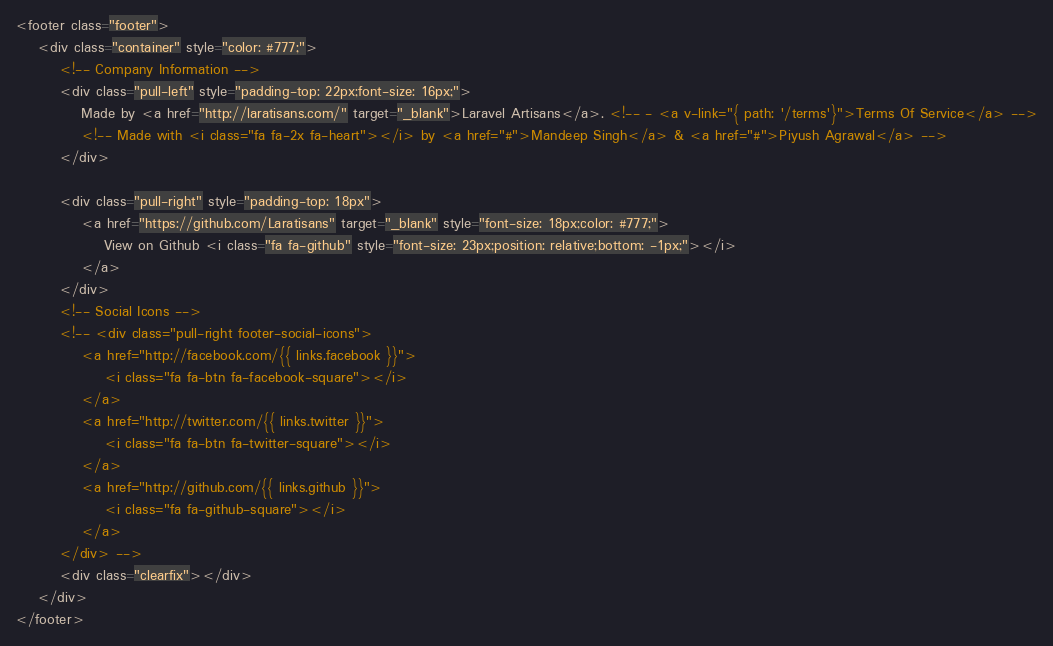Convert code to text. <code><loc_0><loc_0><loc_500><loc_500><_HTML_>
<footer class="footer">
	<div class="container" style="color: #777;">
		<!-- Company Information -->
		<div class="pull-left" style="padding-top: 22px;font-size: 16px;">
			Made by <a href="http://laratisans.com/" target="_blank">Laravel Artisans</a>. <!-- - <a v-link="{ path: '/terms'}">Terms Of Service</a> -->
			<!-- Made with <i class="fa fa-2x fa-heart"></i> by <a href="#">Mandeep Singh</a> & <a href="#">Piyush Agrawal</a> -->
		</div>

		<div class="pull-right" style="padding-top: 18px">
			<a href="https://github.com/Laratisans" target="_blank" style="font-size: 18px;color: #777;">
				View on Github <i class="fa fa-github" style="font-size: 23px;position: relative;bottom: -1px;"></i>
			</a>
		</div>
		<!-- Social Icons -->
		<!-- <div class="pull-right footer-social-icons">
			<a href="http://facebook.com/{{ links.facebook }}">
				<i class="fa fa-btn fa-facebook-square"></i>
			</a>
			<a href="http://twitter.com/{{ links.twitter }}">
				<i class="fa fa-btn fa-twitter-square"></i>
			</a>
			<a href="http://github.com/{{ links.github }}">
				<i class="fa fa-github-square"></i>
			</a>
		</div> -->
		<div class="clearfix"></div>
	</div>
</footer>

</code> 